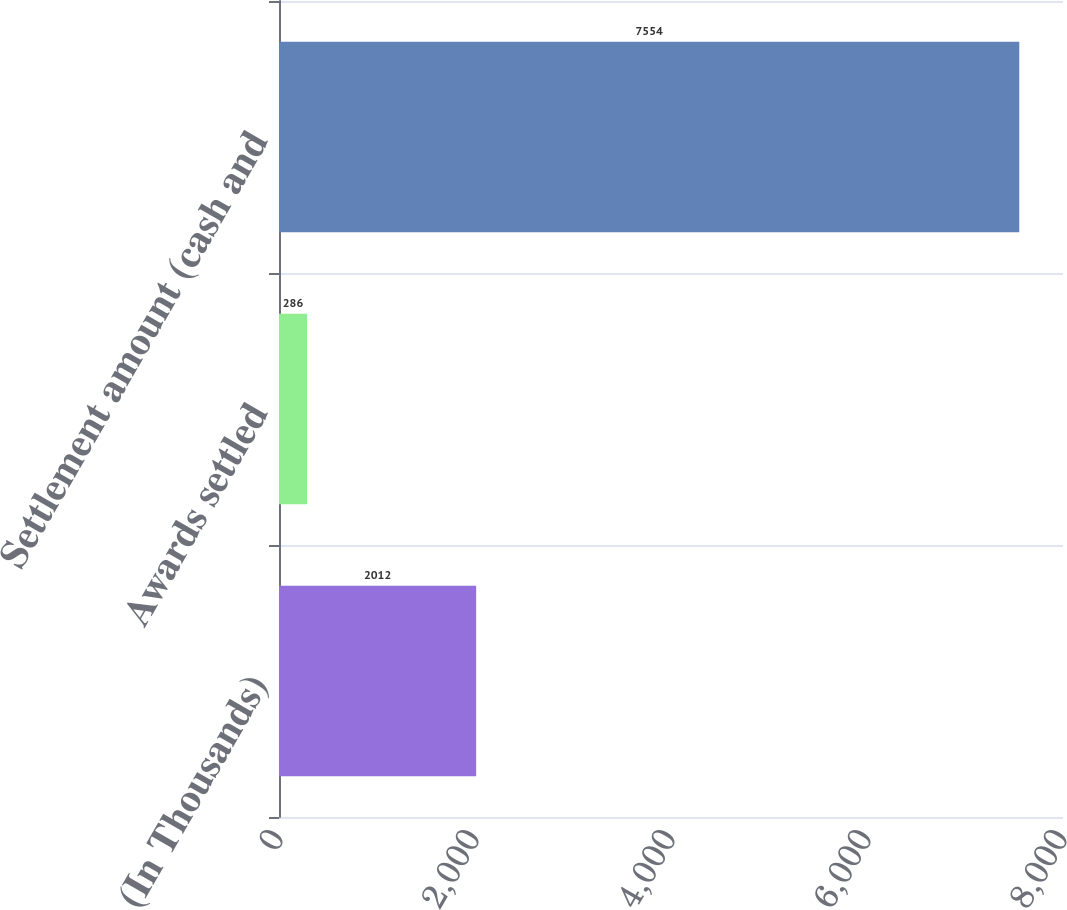Convert chart. <chart><loc_0><loc_0><loc_500><loc_500><bar_chart><fcel>(In Thousands)<fcel>Awards settled<fcel>Settlement amount (cash and<nl><fcel>2012<fcel>286<fcel>7554<nl></chart> 